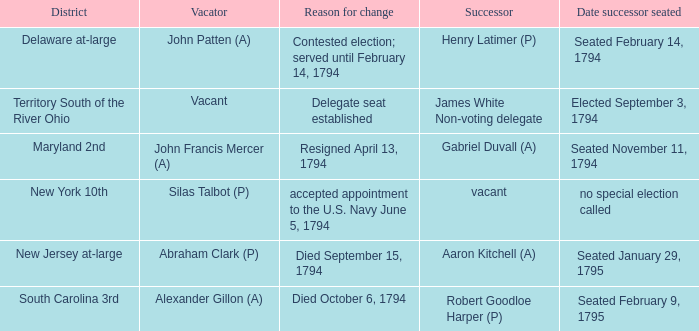What is the date the successor assumed their position in south carolina's 3rd area? Seated February 9, 1795. 